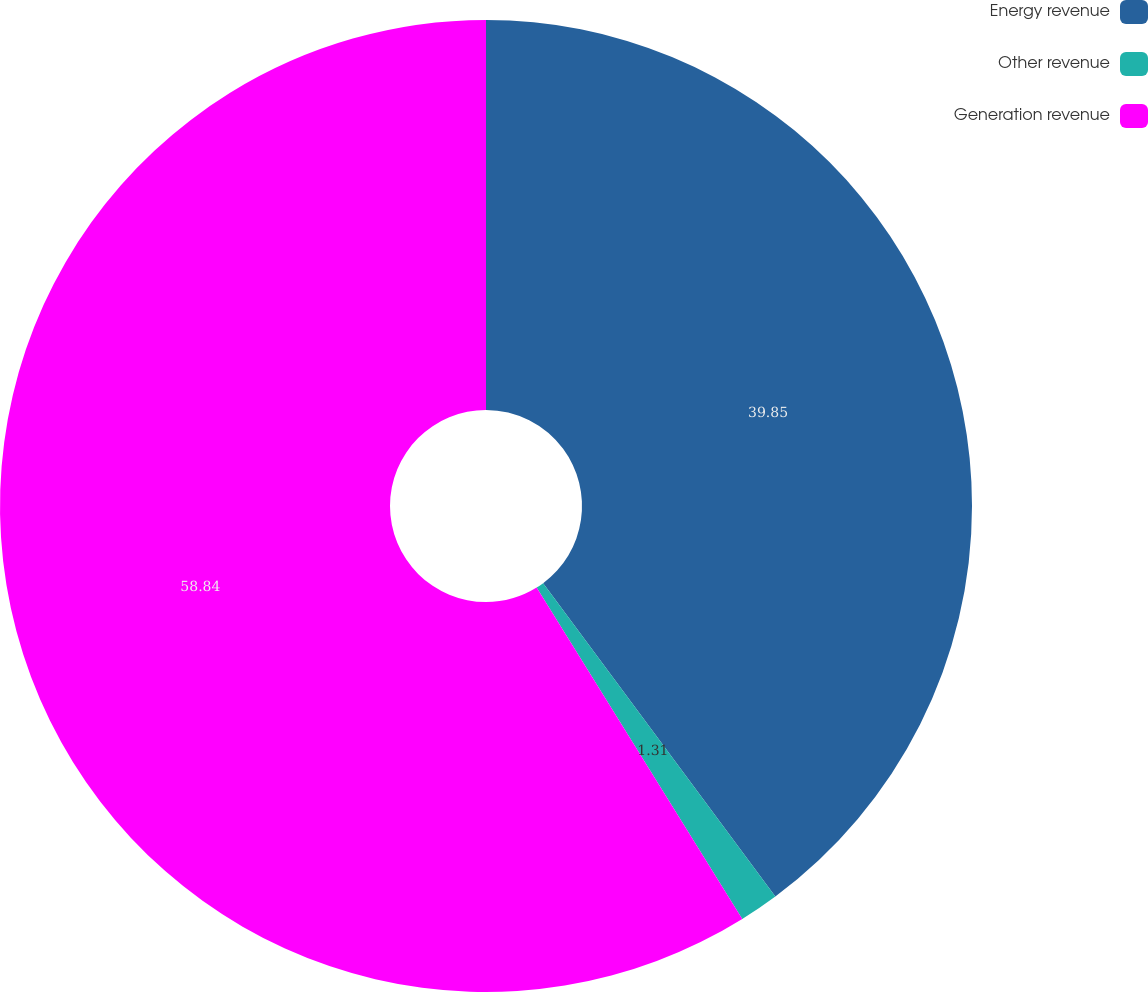Convert chart. <chart><loc_0><loc_0><loc_500><loc_500><pie_chart><fcel>Energy revenue<fcel>Other revenue<fcel>Generation revenue<nl><fcel>39.85%<fcel>1.31%<fcel>58.84%<nl></chart> 